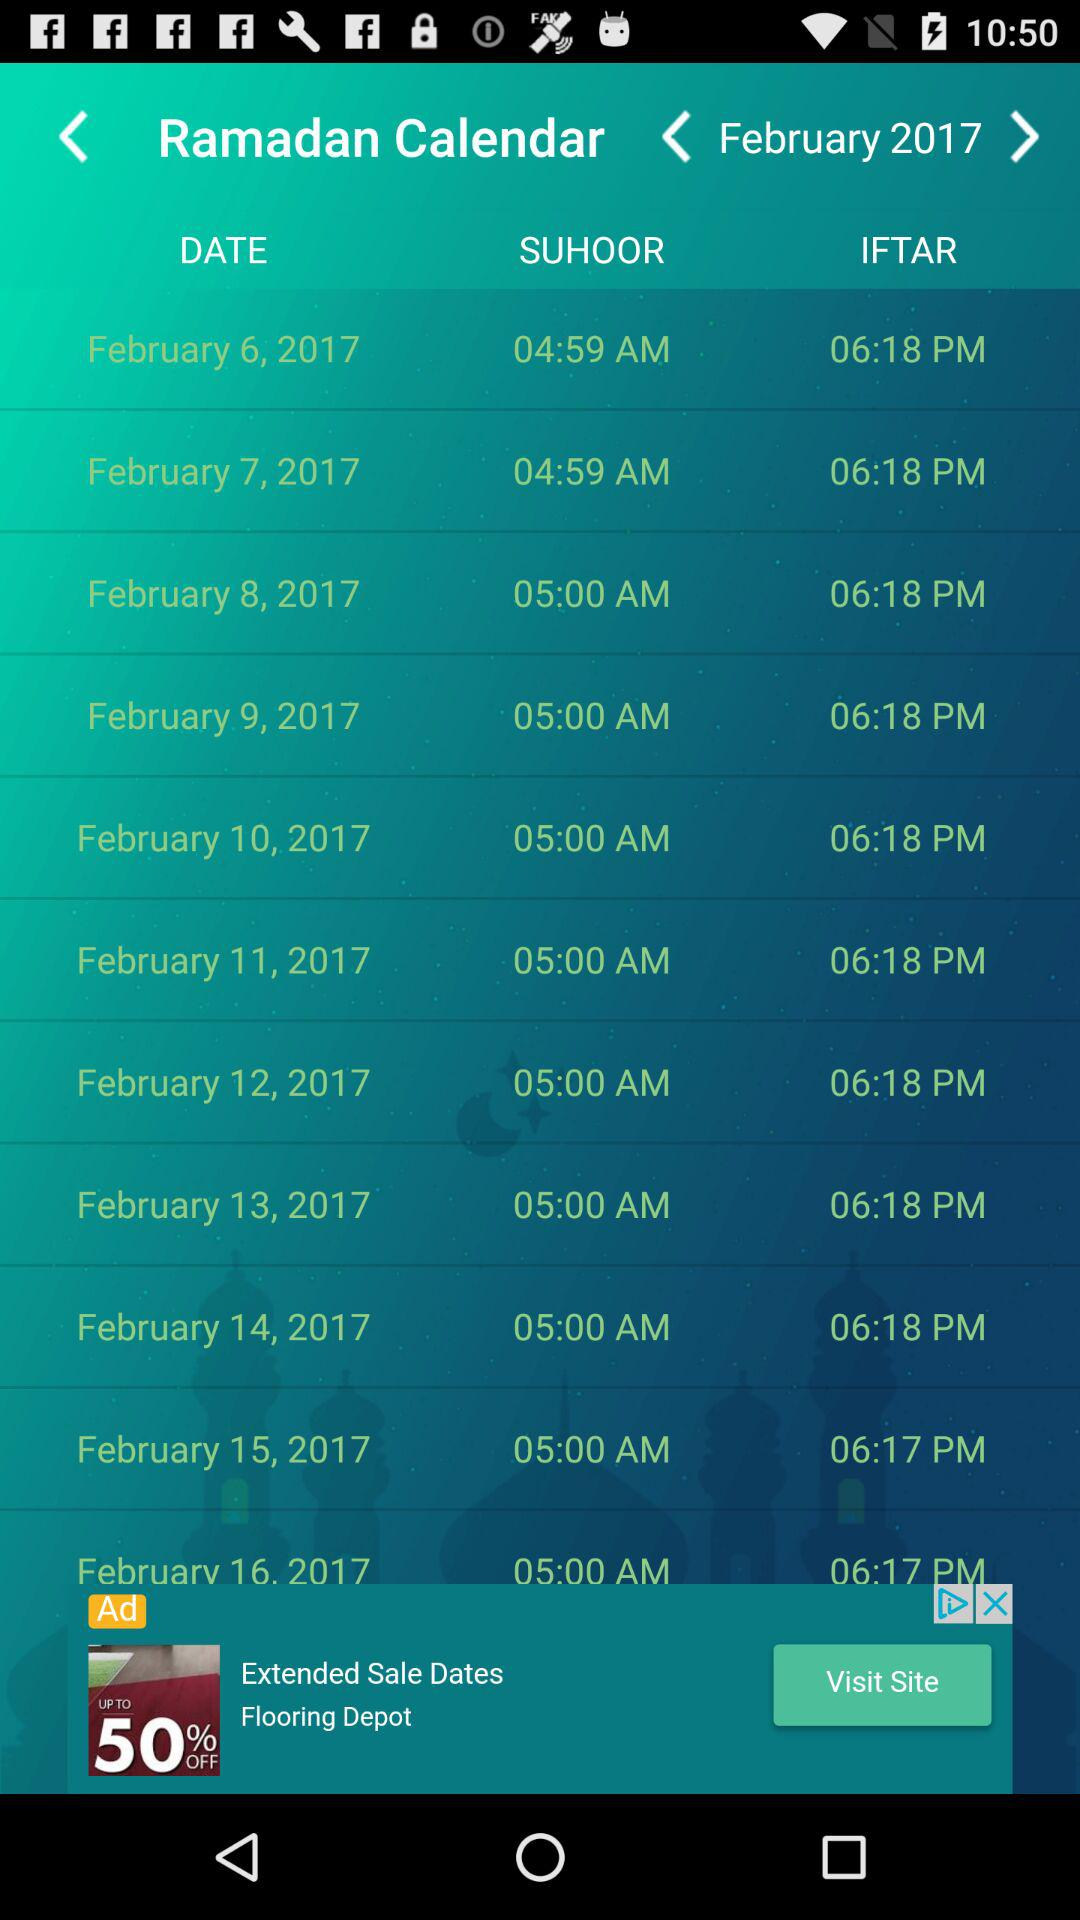What is the selected year? The selected year is 2017. 